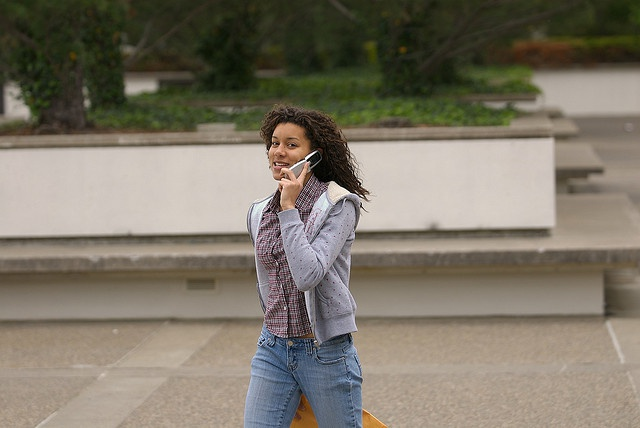Describe the objects in this image and their specific colors. I can see bench in darkgreen, lightgray, gray, and darkgray tones, people in darkgreen, gray, darkgray, and black tones, bench in darkgreen, gray, and darkgray tones, bench in darkgreen, darkgray, gray, and black tones, and bench in darkgreen, black, darkgray, and gray tones in this image. 